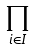<formula> <loc_0><loc_0><loc_500><loc_500>\prod _ { i \in I }</formula> 